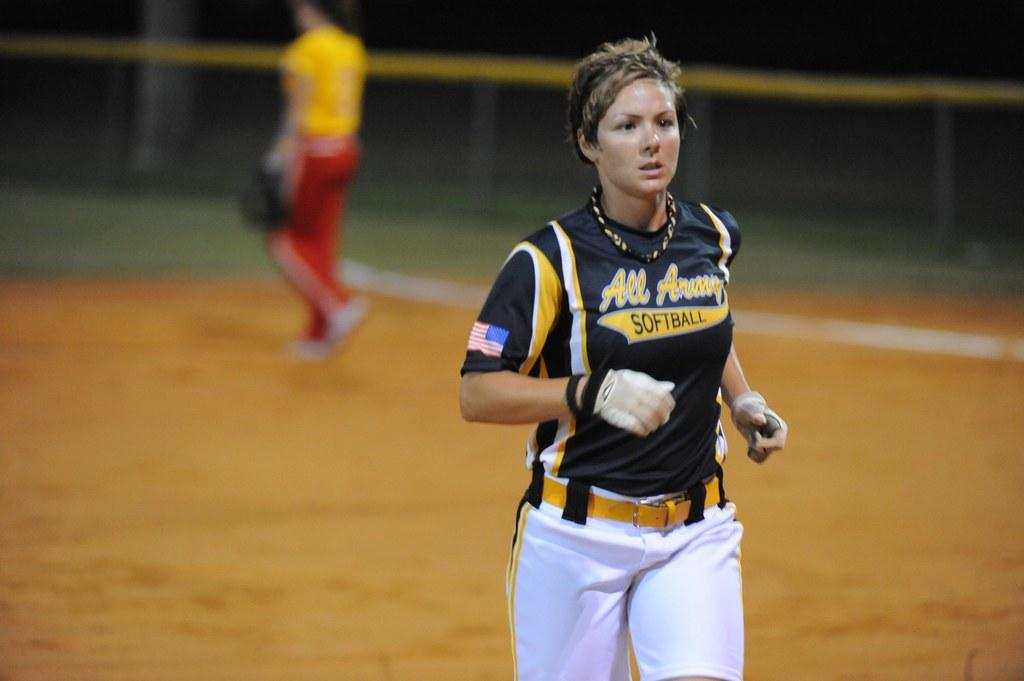Provide a one-sentence caption for the provided image. A female player with the word softball on her black jersey. 